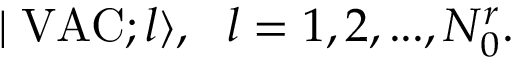Convert formula to latex. <formula><loc_0><loc_0><loc_500><loc_500>| V A C ; l \rangle , \, l = 1 , 2 , \dots , N _ { 0 } ^ { r } .</formula> 